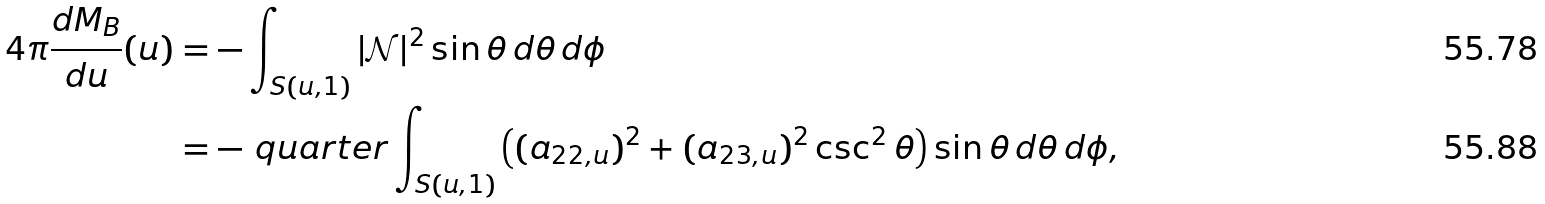Convert formula to latex. <formula><loc_0><loc_0><loc_500><loc_500>4 \pi \frac { d M _ { B } } { d u } ( u ) & = - \int _ { S ( u , 1 ) } | \mathcal { N } | ^ { 2 } \sin \theta \, d \theta \, d \phi \\ & = - \ q u a r t e r \int _ { S ( u , 1 ) } \left ( ( a _ { 2 2 , u } ) ^ { 2 } + ( a _ { 2 3 , u } ) ^ { 2 } \csc ^ { 2 } \theta \right ) \sin \theta \, d \theta \, d \phi ,</formula> 